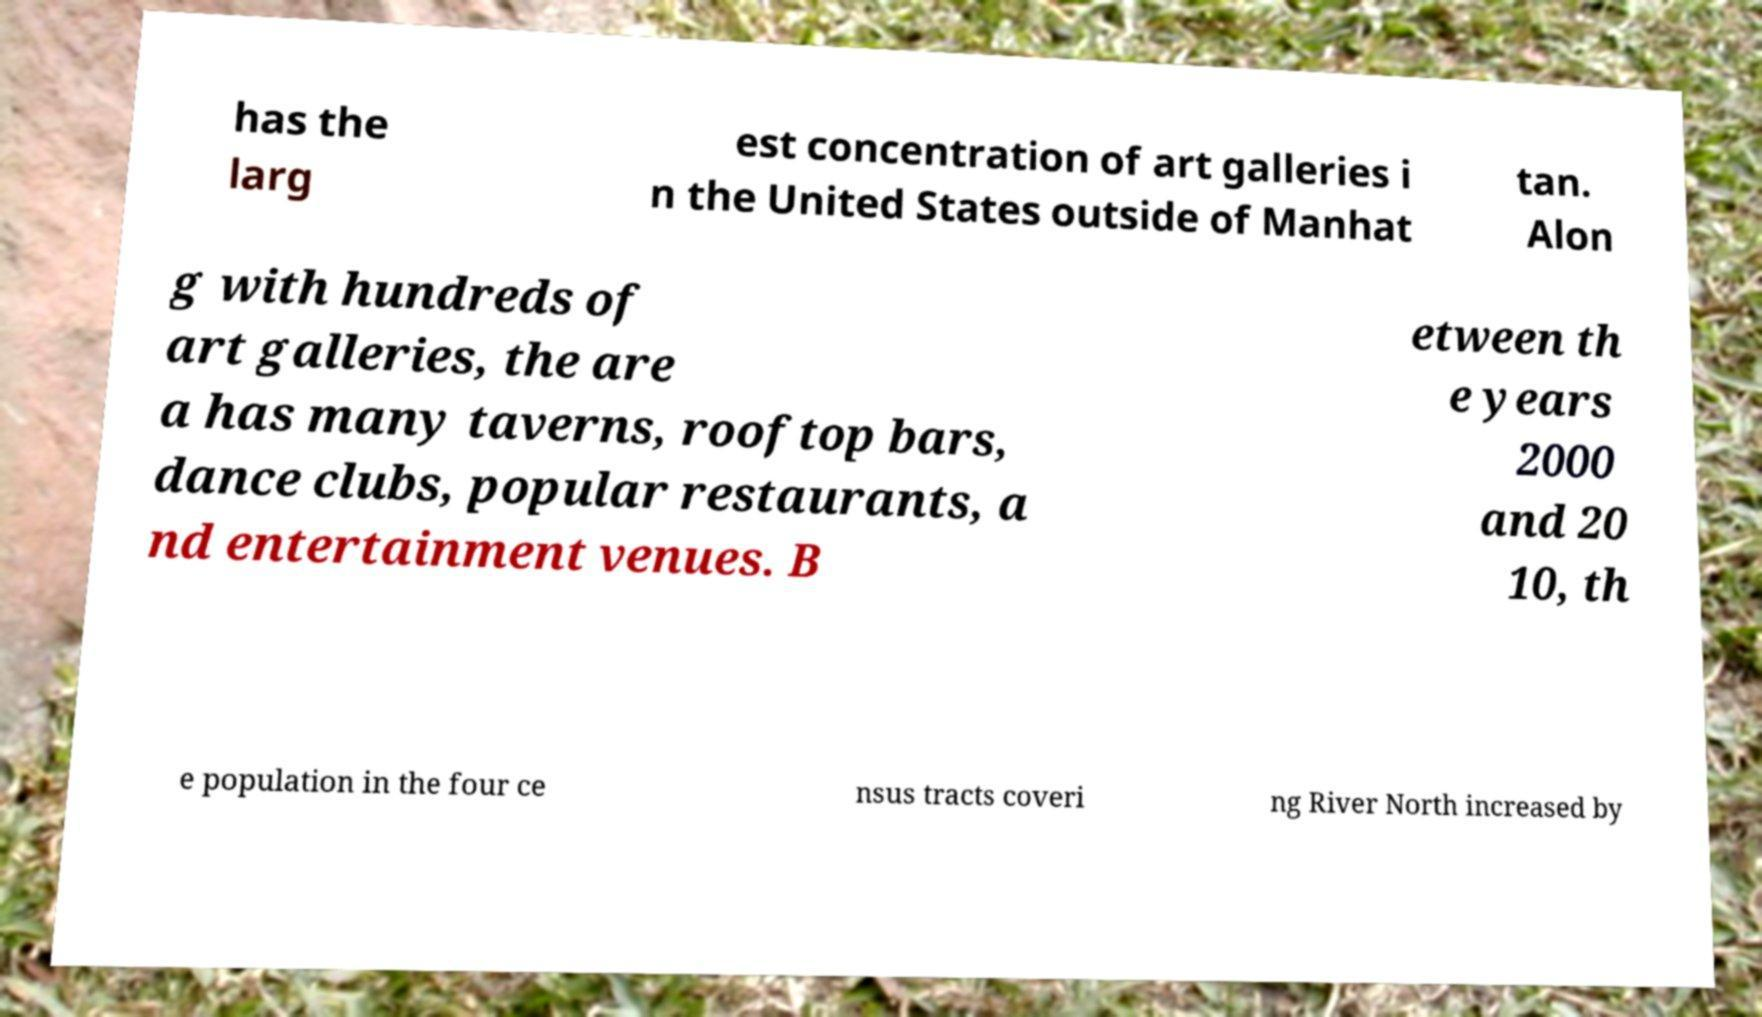Please read and relay the text visible in this image. What does it say? has the larg est concentration of art galleries i n the United States outside of Manhat tan. Alon g with hundreds of art galleries, the are a has many taverns, rooftop bars, dance clubs, popular restaurants, a nd entertainment venues. B etween th e years 2000 and 20 10, th e population in the four ce nsus tracts coveri ng River North increased by 